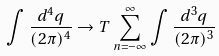<formula> <loc_0><loc_0><loc_500><loc_500>\int \frac { d ^ { 4 } q } { ( 2 \pi ) ^ { 4 } } \rightarrow T \sum _ { n = - \infty } ^ { \infty } \int \frac { d ^ { 3 } q } { ( 2 \pi ) ^ { 3 } }</formula> 